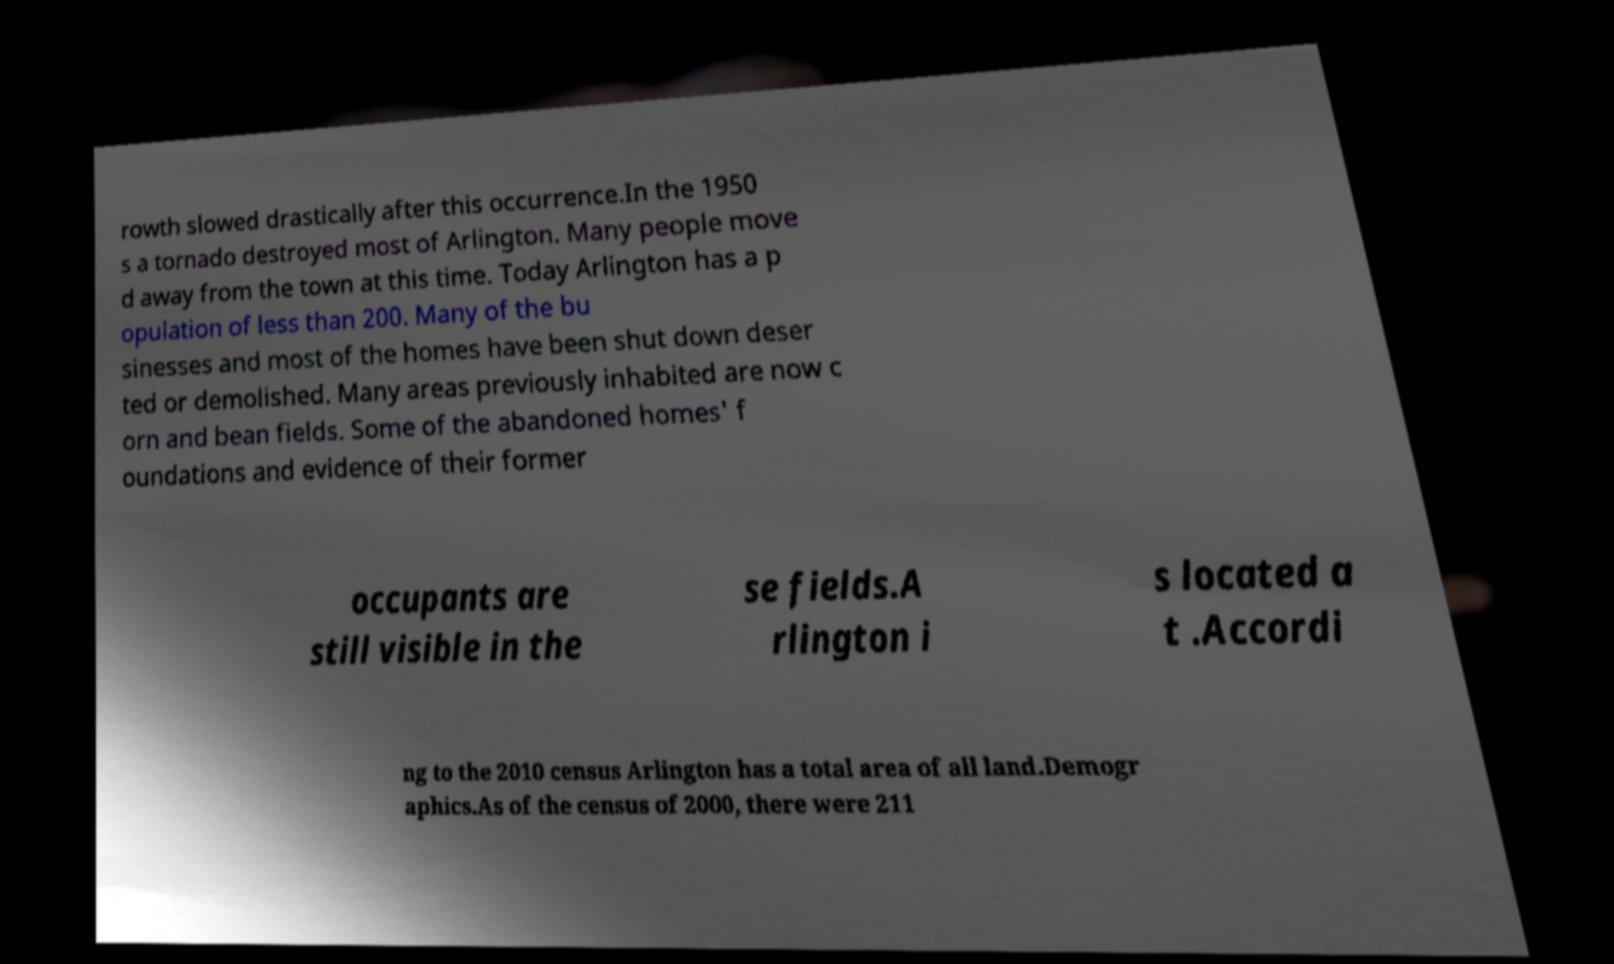For documentation purposes, I need the text within this image transcribed. Could you provide that? rowth slowed drastically after this occurrence.In the 1950 s a tornado destroyed most of Arlington. Many people move d away from the town at this time. Today Arlington has a p opulation of less than 200. Many of the bu sinesses and most of the homes have been shut down deser ted or demolished. Many areas previously inhabited are now c orn and bean fields. Some of the abandoned homes' f oundations and evidence of their former occupants are still visible in the se fields.A rlington i s located a t .Accordi ng to the 2010 census Arlington has a total area of all land.Demogr aphics.As of the census of 2000, there were 211 